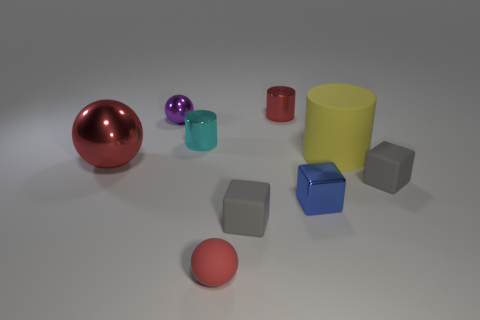Add 1 big gray cylinders. How many objects exist? 10 Subtract all spheres. How many objects are left? 6 Subtract all big red things. Subtract all large metallic balls. How many objects are left? 7 Add 1 rubber cubes. How many rubber cubes are left? 3 Add 8 tiny blue metallic things. How many tiny blue metallic things exist? 9 Subtract 1 cyan cylinders. How many objects are left? 8 